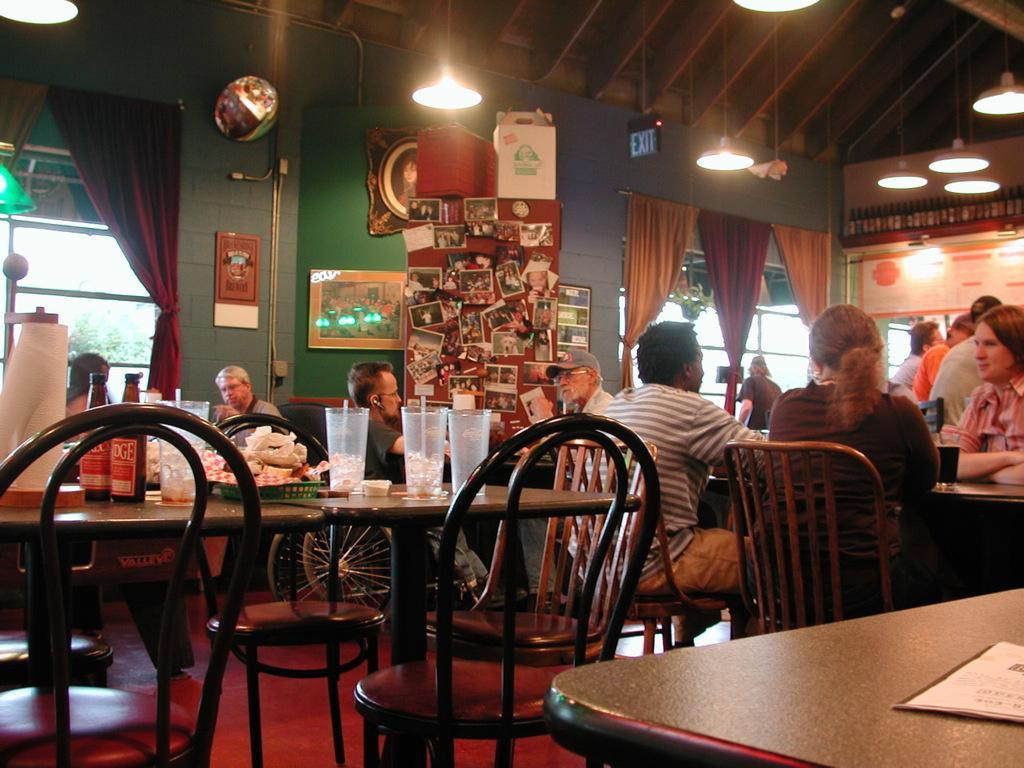How would you summarize this image in a sentence or two? In this image there are group of people who are sitting in front of them there are tables on that table there are glasses, straws, bottles and some papers are there on the table. On the top of the image there is ceiling and lights are there and in the middle of the image there are two windows and curtains and lamps are there in the middle of the image there is wall on the wall there are some photo frames. 